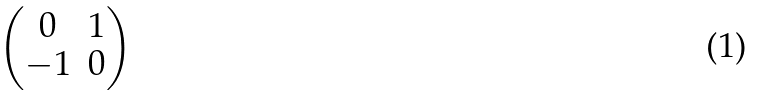<formula> <loc_0><loc_0><loc_500><loc_500>\begin{pmatrix} 0 & { 1 } \\ - { 1 } & 0 \end{pmatrix}</formula> 